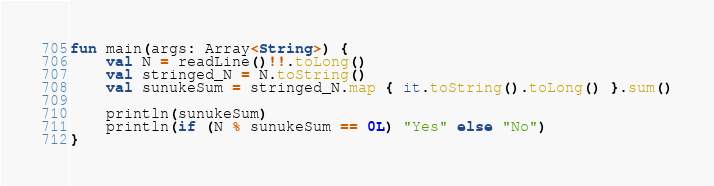<code> <loc_0><loc_0><loc_500><loc_500><_Kotlin_>fun main(args: Array<String>) {
    val N = readLine()!!.toLong()
    val stringed_N = N.toString()
    val sunukeSum = stringed_N.map { it.toString().toLong() }.sum()

    println(sunukeSum)
    println(if (N % sunukeSum == 0L) "Yes" else "No")
}</code> 